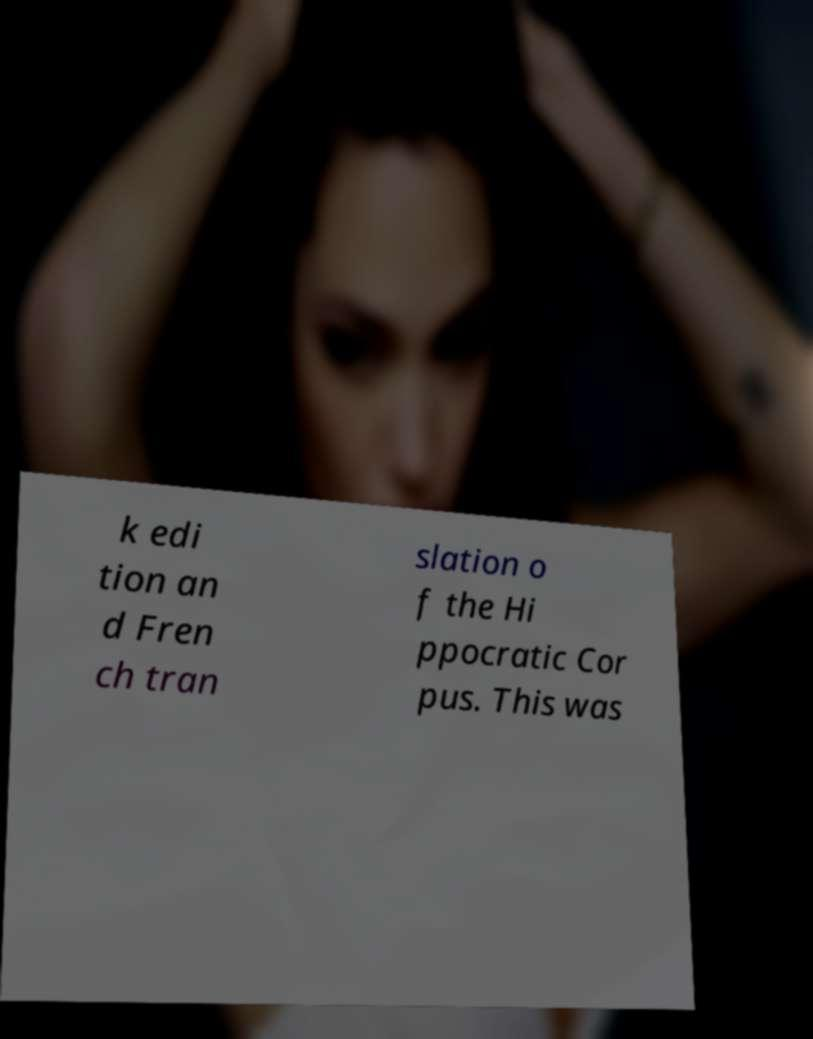There's text embedded in this image that I need extracted. Can you transcribe it verbatim? k edi tion an d Fren ch tran slation o f the Hi ppocratic Cor pus. This was 